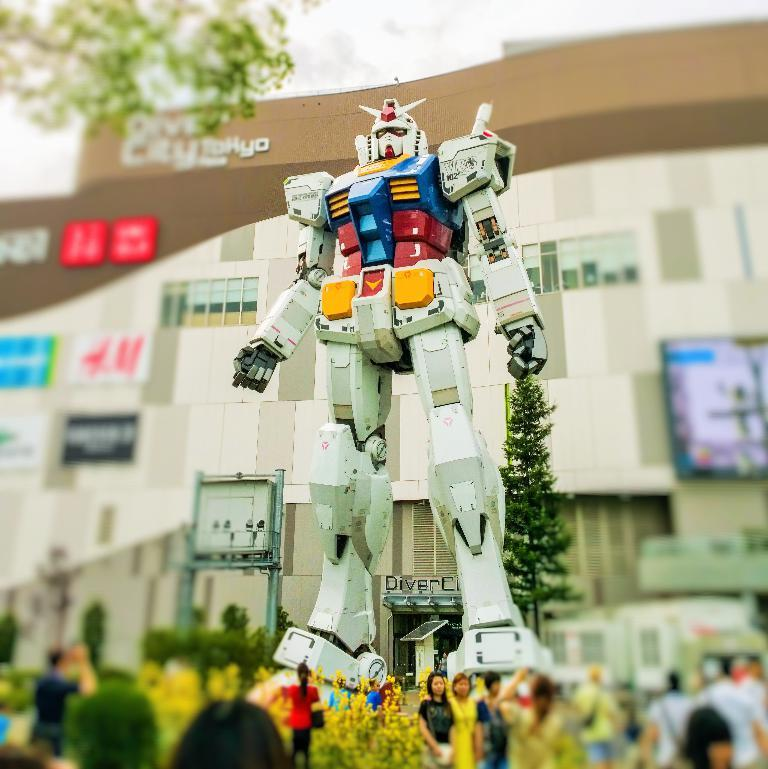How many people are in the image? There is a group of people in the image, but the exact number cannot be determined from the provided facts. What type of flora is present in the image? There are flowers and trees in the image. What type of structure is visible in the image? There is a building in the image. What is the giant toy in the image? There is a giant robot toy in the image. What type of birds can be seen flying around the pet in the image? There is no mention of birds or pets in the image; it features a group of people, flowers, trees, a building, and a giant robot toy. 